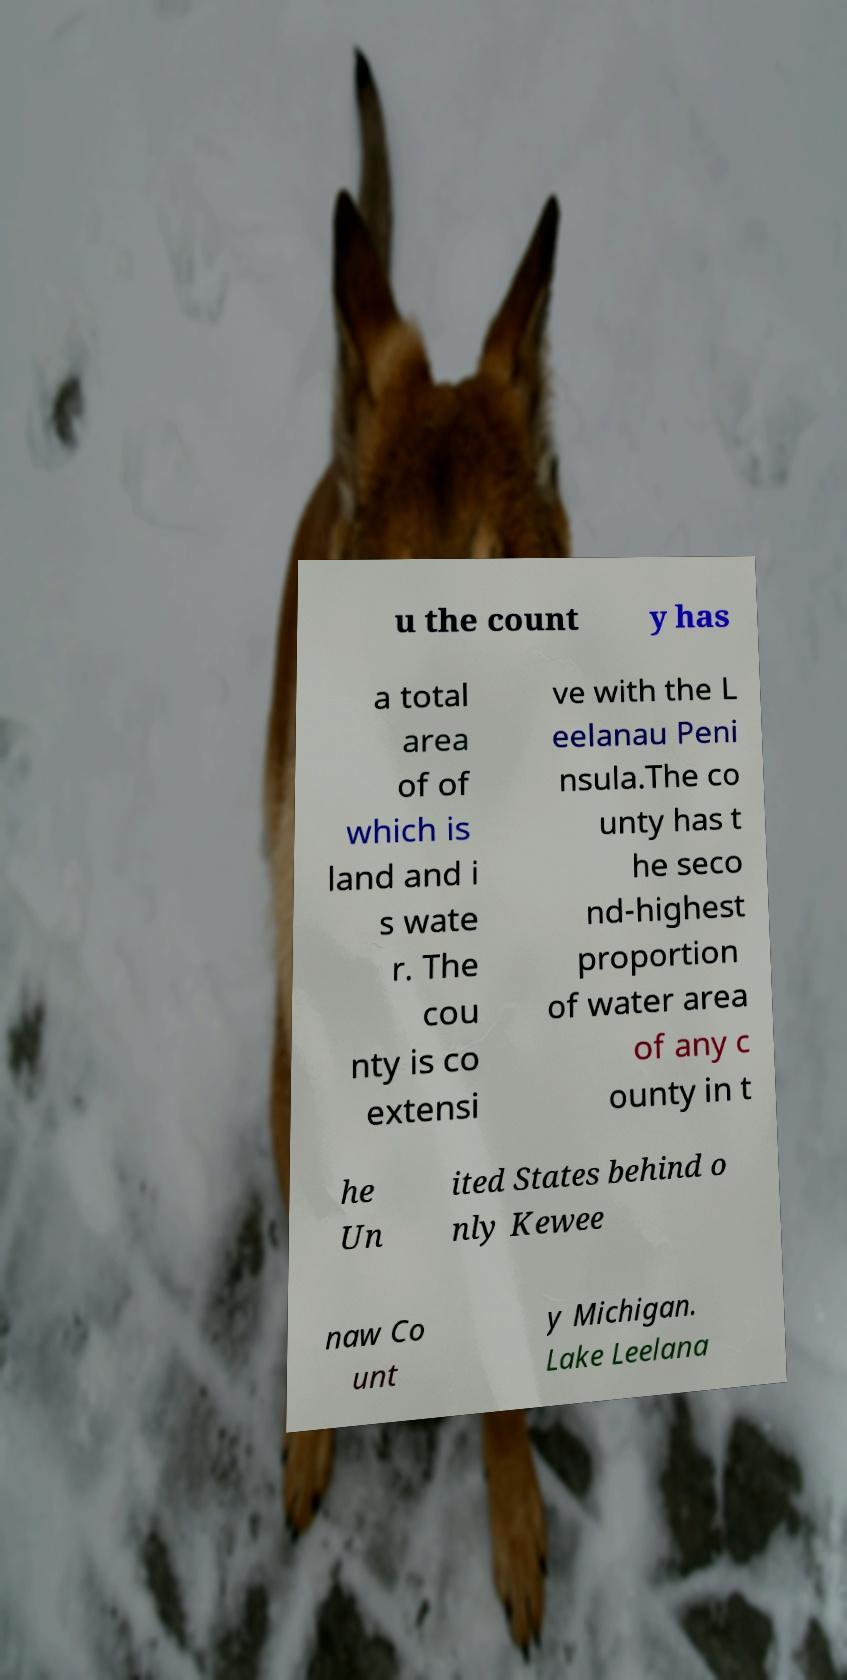What messages or text are displayed in this image? I need them in a readable, typed format. u the count y has a total area of of which is land and i s wate r. The cou nty is co extensi ve with the L eelanau Peni nsula.The co unty has t he seco nd-highest proportion of water area of any c ounty in t he Un ited States behind o nly Kewee naw Co unt y Michigan. Lake Leelana 